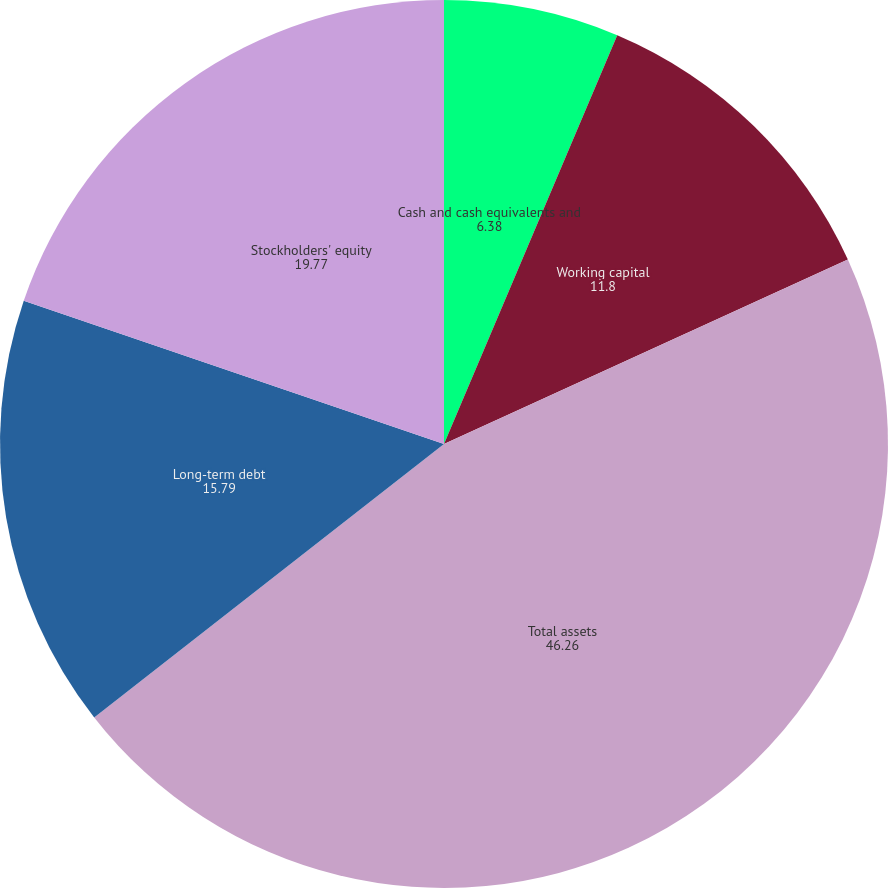<chart> <loc_0><loc_0><loc_500><loc_500><pie_chart><fcel>Cash and cash equivalents and<fcel>Working capital<fcel>Total assets<fcel>Long-term debt<fcel>Stockholders' equity<nl><fcel>6.38%<fcel>11.8%<fcel>46.26%<fcel>15.79%<fcel>19.77%<nl></chart> 